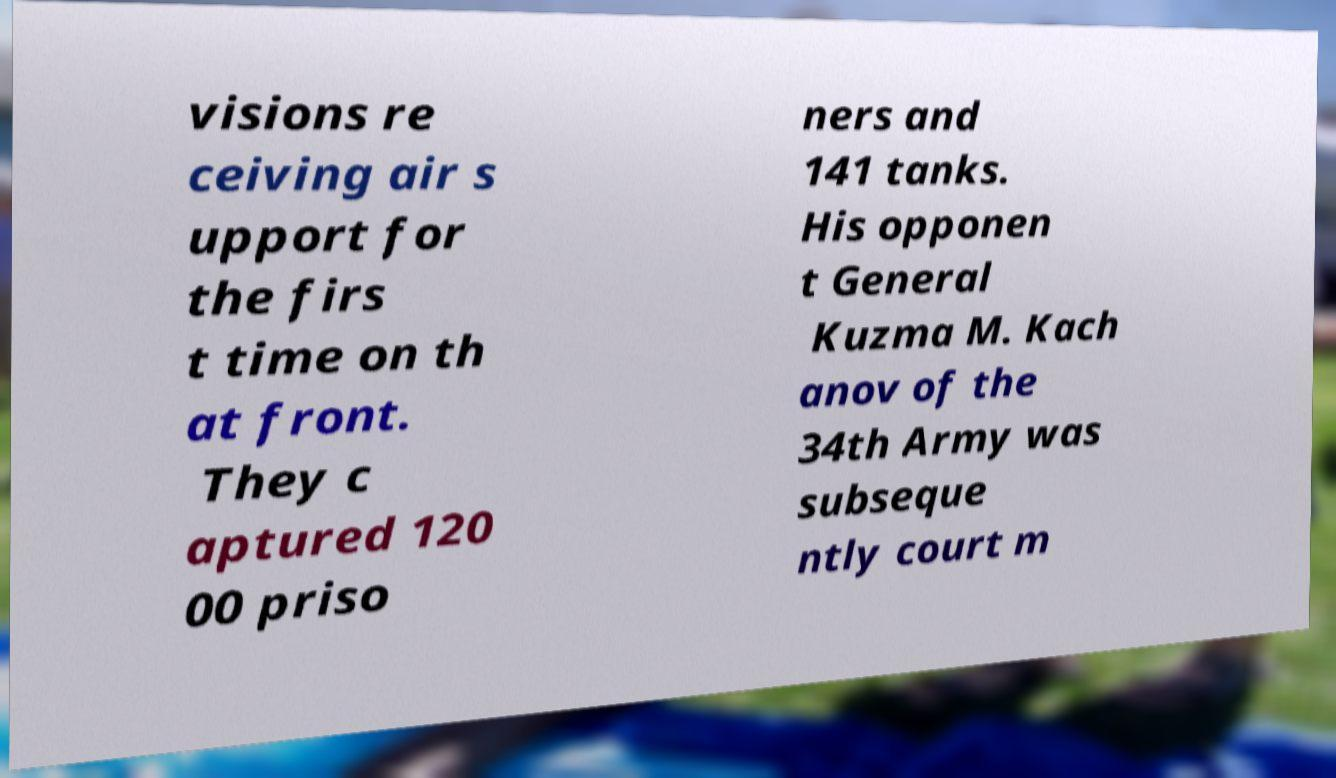What messages or text are displayed in this image? I need them in a readable, typed format. visions re ceiving air s upport for the firs t time on th at front. They c aptured 120 00 priso ners and 141 tanks. His opponen t General Kuzma M. Kach anov of the 34th Army was subseque ntly court m 